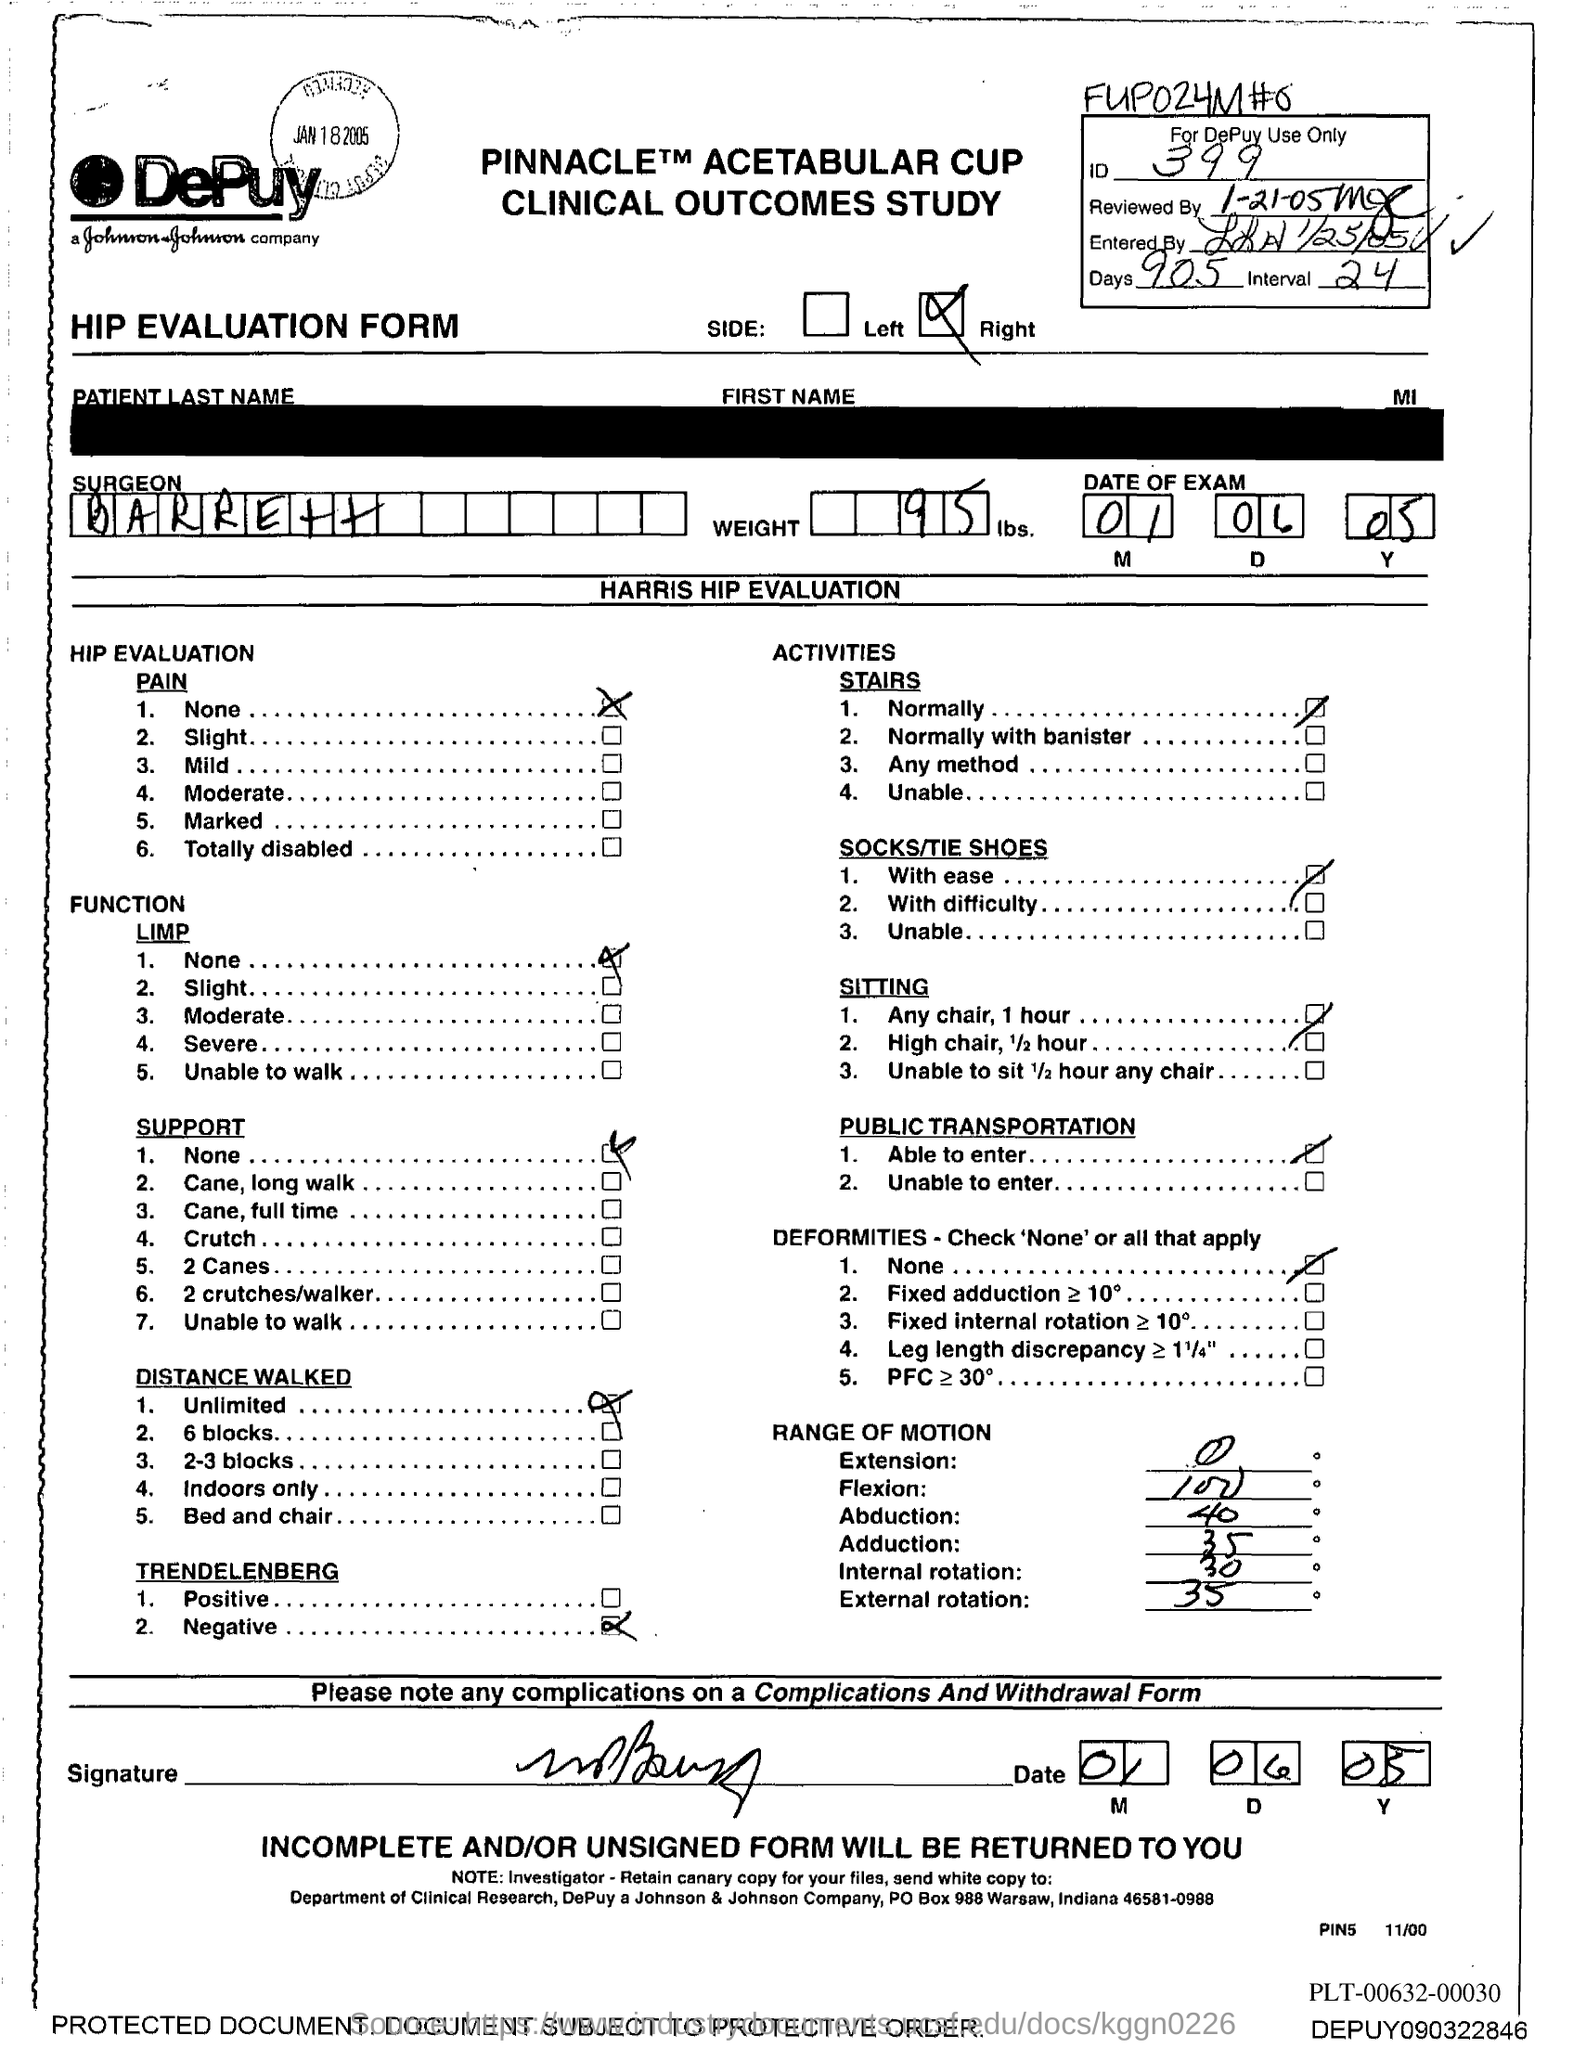What is the ID Number?
Keep it short and to the point. 399. What is the Weight?
Ensure brevity in your answer.  95. What is the name of the Surgeon?
Provide a short and direct response. Barrett. 